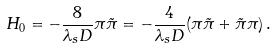<formula> <loc_0><loc_0><loc_500><loc_500>H _ { 0 } = - \frac { 8 } { \lambda _ { s } D } \pi \tilde { \pi } = - \frac { 4 } { \lambda _ { s } D } ( \pi \tilde { \pi } + \tilde { \pi } \pi ) \, .</formula> 